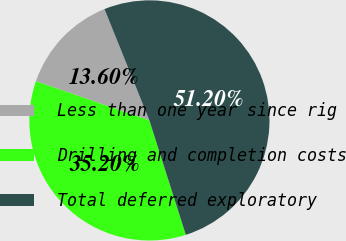<chart> <loc_0><loc_0><loc_500><loc_500><pie_chart><fcel>Less than one year since rig<fcel>Drilling and completion costs<fcel>Total deferred exploratory<nl><fcel>13.6%<fcel>35.2%<fcel>51.2%<nl></chart> 